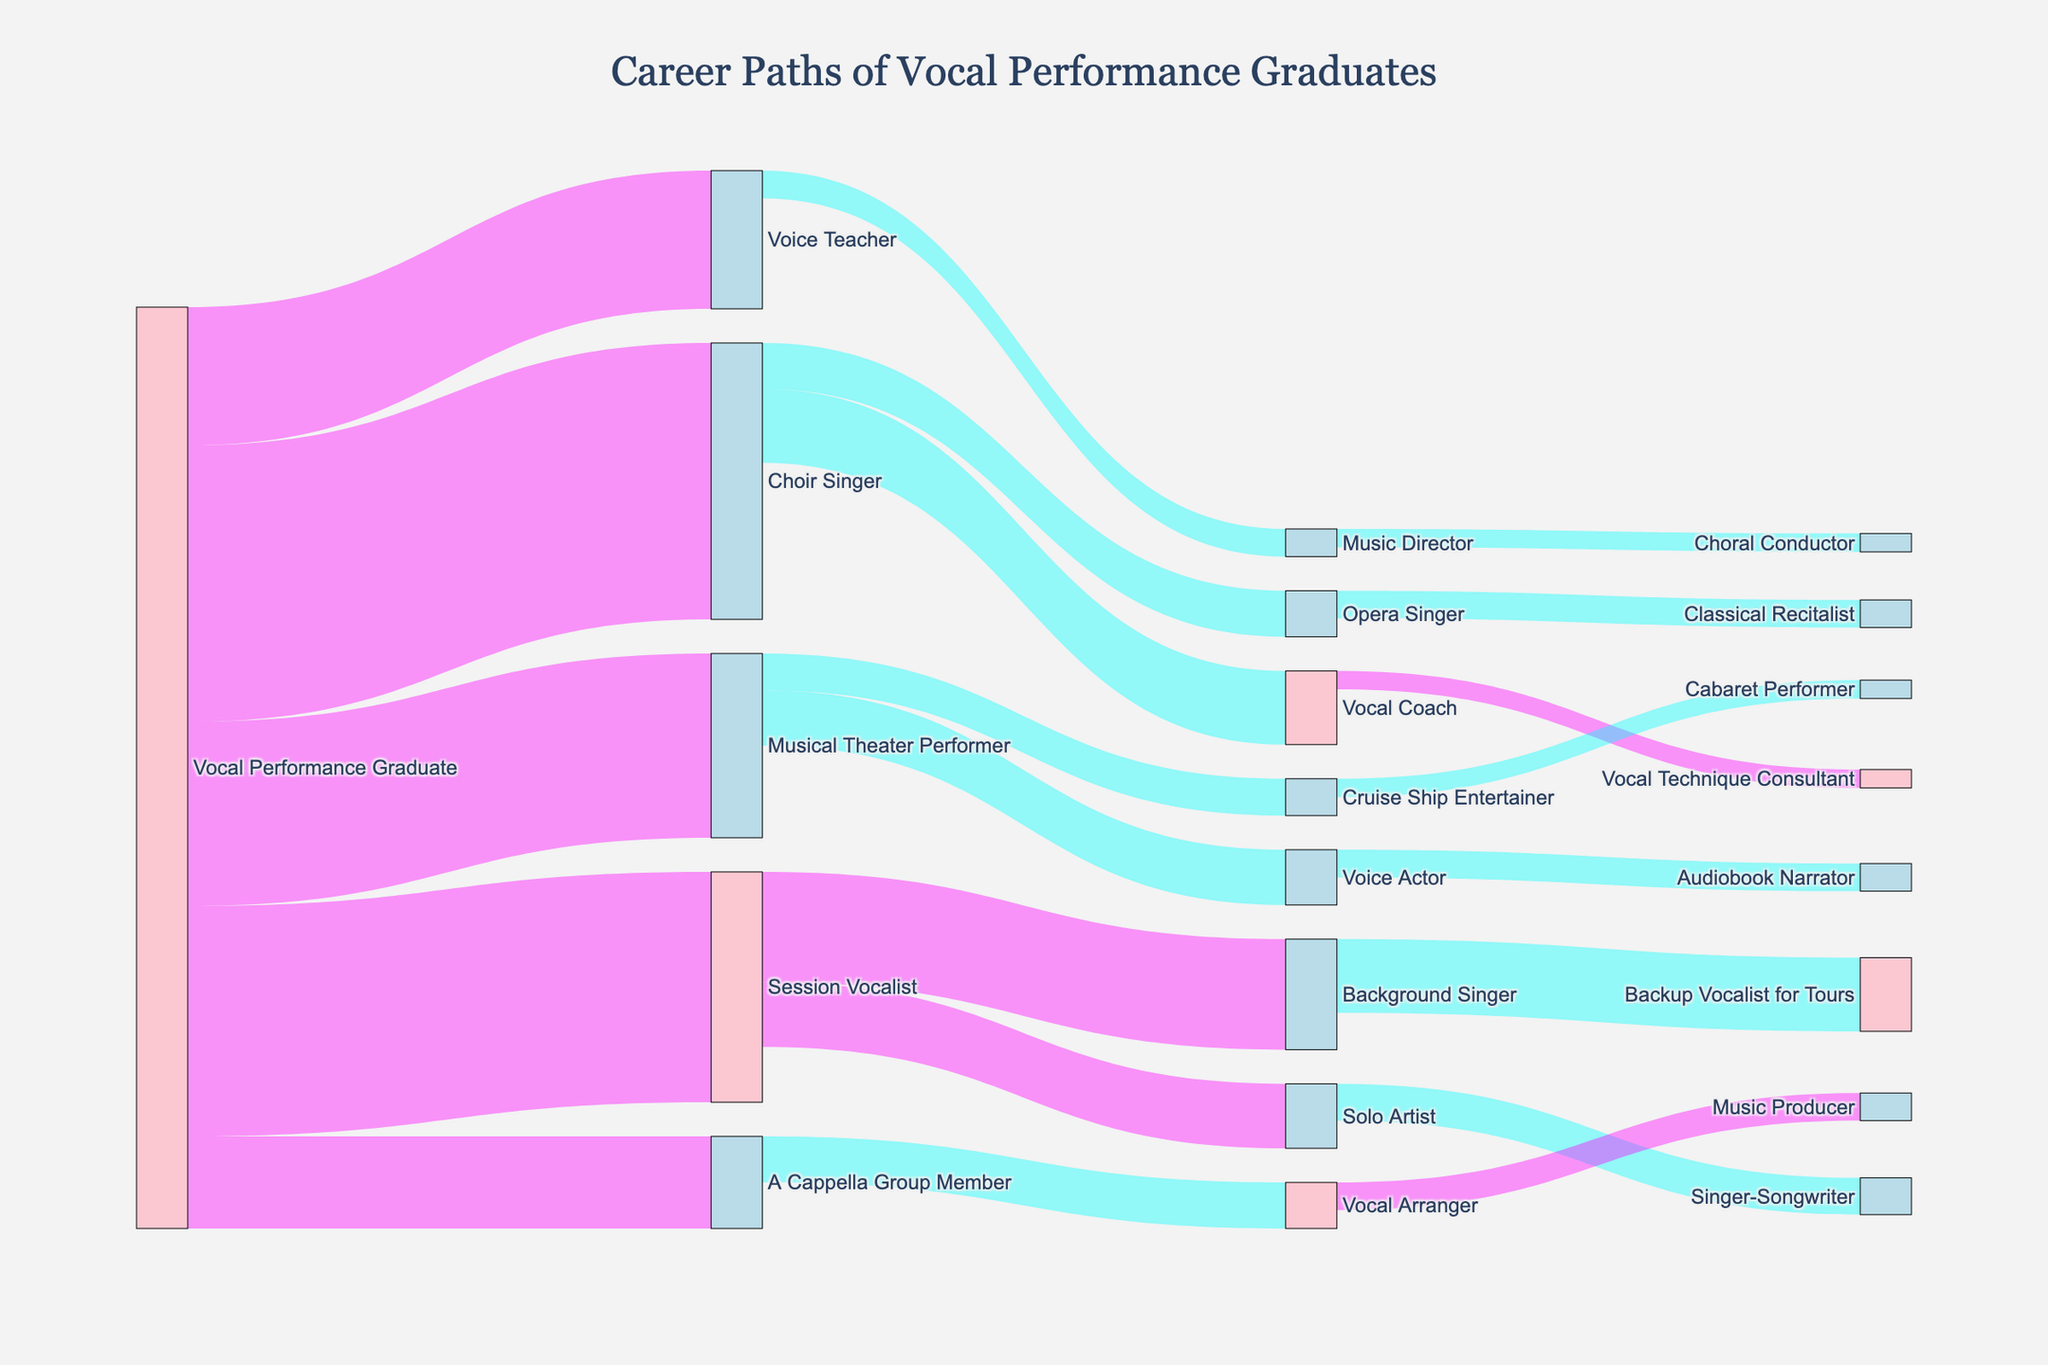What's the title of the figure? The title is typically displayed prominently at the top center of most figures. Reading it directly from the top of the figure will give the title.
Answer: Career Paths of Vocal Performance Graduates What is the most common career path for vocal performance graduates? Look for the source that has the highest value flowing out from it. In this case, it's the "Vocal Performance Graduate" transitioning to "Choir Singer" with a value of 30.
Answer: Choir Singer How many graduates become Voice Teachers? Identify the transition from "Vocal Performance Graduate" to "Voice Teacher" and note the value.
Answer: 15 Which career paths have a flow value of 5? Look for transitions with the value of 5. These include "Choir Singer" to "Opera Singer" and "A Cappella Group Member" to "Vocal Arranger".
Answer: Choir Singer to Opera Singer, A Cappella Group Member to Vocal Arranger What is the total number of graduates transitioning from the Choir Singer role? Sum all the values of transitions originating from "Choir Singer" (8 to Vocal Coach + 5 to Opera Singer).
Answer: 13 Which path has the smallest flow value and what is it? Identify the path with the smallest numerical value. This is "Vocal Coach" transitioning to "Vocal Technique Consultant" with a value of 2.
Answer: Vocal Coach to Vocal Technique Consultant, 2 How many graduates transition into roles related to teaching and coaching (Voice Teacher, Vocal Coach, Music Director)? Identify and sum the transitions into roles that are related to teaching and coaching: Voice Teacher (15) + Vocal Coach (8) + Music Director (3).
Answer: 26 Which career path involves more graduates, Solo Artist or Background Singer? Compare the values transitioning into Solo Artist and Background Singer. Solo Artist has 7 and Background Singer has 12.
Answer: Background Singer How many graduates pursue roles in performing (Musical Theater Performer, A Cappella Group Member, Choir Singer)? Sum the values of transitions into these performing roles: Musical Theater Performer (20) + A Cappella Group Member (10) + Choir Singer (30).
Answer: 60 What percentage of graduates become Session Vocalists? Find the value transitioning into the Session Vocalist, then divide it by the total number of graduates and multiply by 100. The total value is 100 (sum of all transitions out of Vocal Performance Graduate). (25 / 100) * 100 = 25%.
Answer: 25% 